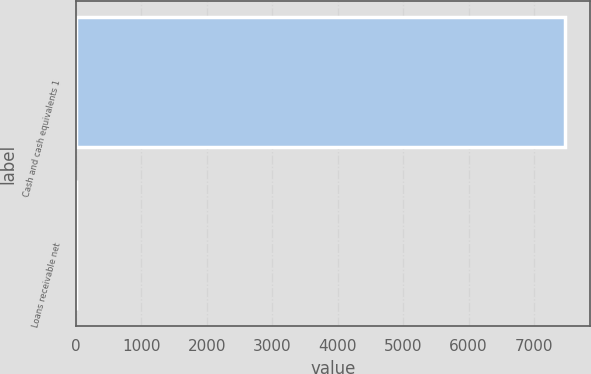Convert chart. <chart><loc_0><loc_0><loc_500><loc_500><bar_chart><fcel>Cash and cash equivalents 1<fcel>Loans receivable net<nl><fcel>7476.8<fcel>2.5<nl></chart> 